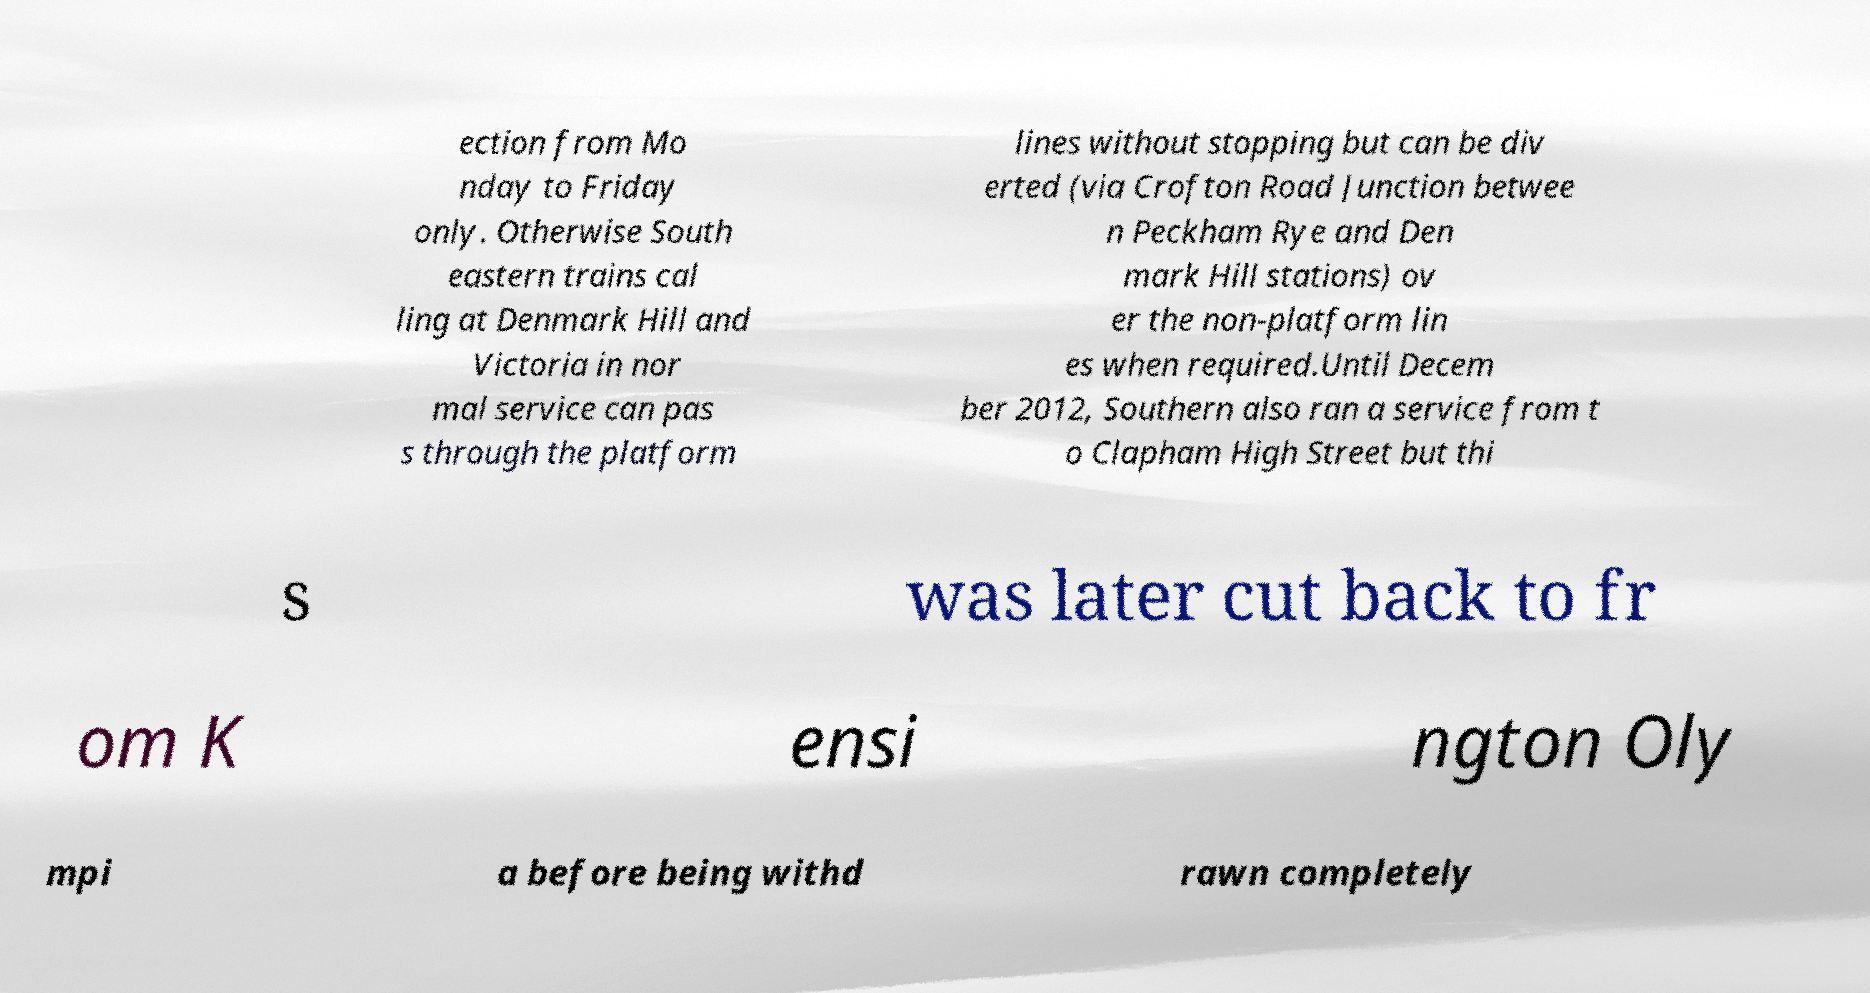Can you read and provide the text displayed in the image?This photo seems to have some interesting text. Can you extract and type it out for me? ection from Mo nday to Friday only. Otherwise South eastern trains cal ling at Denmark Hill and Victoria in nor mal service can pas s through the platform lines without stopping but can be div erted (via Crofton Road Junction betwee n Peckham Rye and Den mark Hill stations) ov er the non-platform lin es when required.Until Decem ber 2012, Southern also ran a service from t o Clapham High Street but thi s was later cut back to fr om K ensi ngton Oly mpi a before being withd rawn completely 